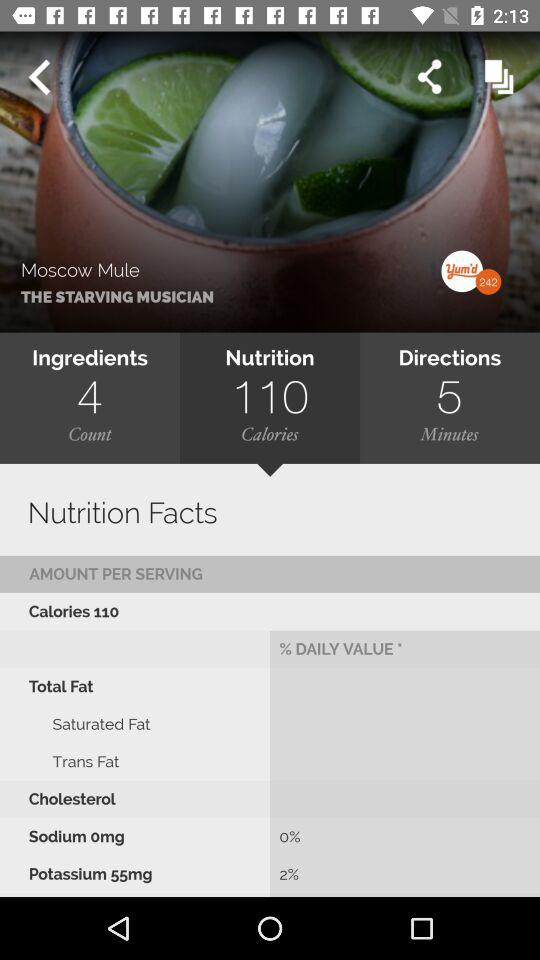What is the calorie count? The calorie count is 110. 